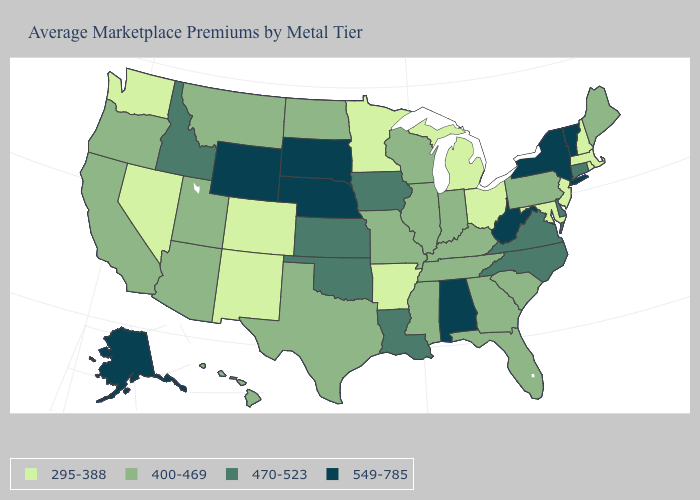Which states have the lowest value in the West?
Concise answer only. Colorado, Nevada, New Mexico, Washington. What is the lowest value in the West?
Answer briefly. 295-388. Name the states that have a value in the range 295-388?
Give a very brief answer. Arkansas, Colorado, Maryland, Massachusetts, Michigan, Minnesota, Nevada, New Hampshire, New Jersey, New Mexico, Ohio, Rhode Island, Washington. What is the value of Illinois?
Give a very brief answer. 400-469. How many symbols are there in the legend?
Answer briefly. 4. What is the value of Missouri?
Answer briefly. 400-469. Name the states that have a value in the range 295-388?
Concise answer only. Arkansas, Colorado, Maryland, Massachusetts, Michigan, Minnesota, Nevada, New Hampshire, New Jersey, New Mexico, Ohio, Rhode Island, Washington. What is the value of Arkansas?
Be succinct. 295-388. Which states have the lowest value in the USA?
Write a very short answer. Arkansas, Colorado, Maryland, Massachusetts, Michigan, Minnesota, Nevada, New Hampshire, New Jersey, New Mexico, Ohio, Rhode Island, Washington. What is the highest value in states that border New York?
Answer briefly. 549-785. Name the states that have a value in the range 295-388?
Write a very short answer. Arkansas, Colorado, Maryland, Massachusetts, Michigan, Minnesota, Nevada, New Hampshire, New Jersey, New Mexico, Ohio, Rhode Island, Washington. What is the value of Delaware?
Concise answer only. 470-523. Is the legend a continuous bar?
Answer briefly. No. What is the highest value in the USA?
Answer briefly. 549-785. What is the value of New Hampshire?
Quick response, please. 295-388. 